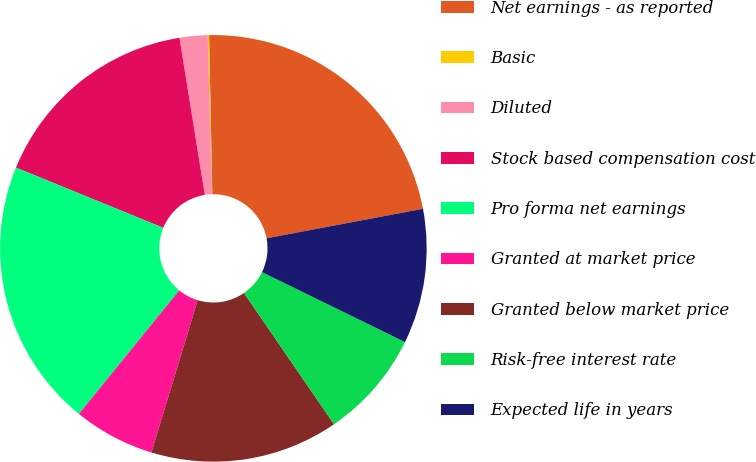Convert chart to OTSL. <chart><loc_0><loc_0><loc_500><loc_500><pie_chart><fcel>Net earnings - as reported<fcel>Basic<fcel>Diluted<fcel>Stock based compensation cost<fcel>Pro forma net earnings<fcel>Granted at market price<fcel>Granted below market price<fcel>Risk-free interest rate<fcel>Expected life in years<nl><fcel>22.35%<fcel>0.1%<fcel>2.12%<fcel>16.28%<fcel>20.32%<fcel>6.17%<fcel>14.26%<fcel>8.19%<fcel>10.21%<nl></chart> 